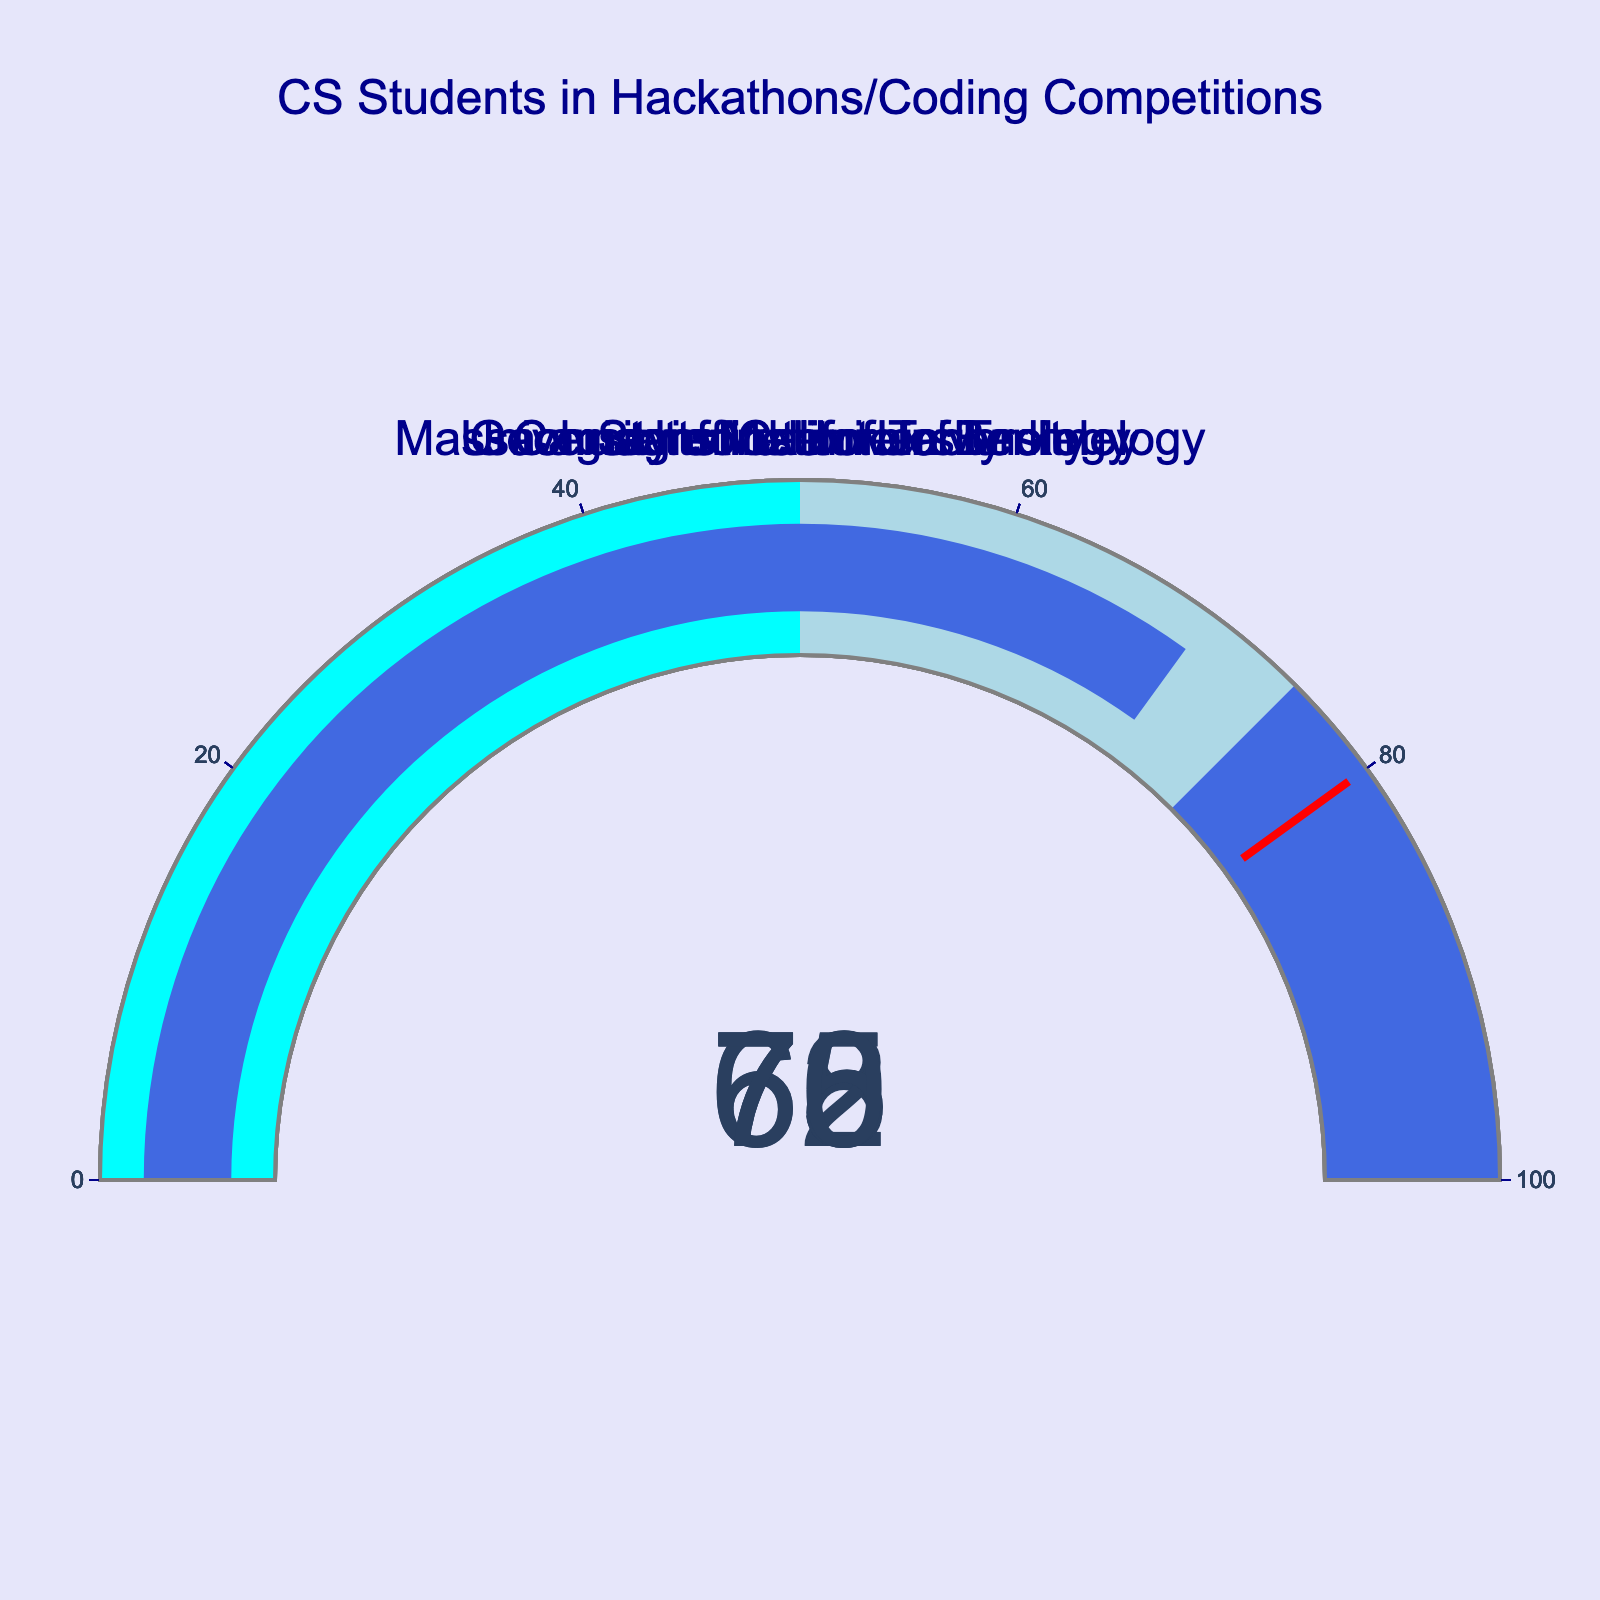What is the title of the figure? The title is displayed at the top of the figure in dark blue font, and it reads "CS Students in Hackathons/Coding Competitions".
Answer: CS Students in Hackathons/Coding Competitions How many universities are included in the figure? The figure includes gauge charts for each of the universities mentioned in the dataset. Counting the names displayed in each gauge chart, we see there are five universities.
Answer: Five Which university has the highest percentage of students participating in hackathons or coding competitions? By looking at each gauge chart, we identify the university with the highest value on the gauge. Carnegie Mellon University shows a value of 75%, which is the highest percentage among the universities.
Answer: Carnegie Mellon University What is the range for the gauge axis? The gauge axis range is indicated with tick marks, and each gauge chart has values ranging from 0 to 100.
Answer: 0 to 100 What percentage of students at the University of California Berkeley participate in hackathons or coding competitions? The gauge chart for the University of California Berkeley shows a value, which is the percentage of students participating in hackathons or coding competitions. This value is 65%.
Answer: 65% Calculate the average percentage of students participating across all universities. We need to sum up the percentages for all universities and then divide by the number of universities: (68 + 72 + 75 + 65 + 70) / 5 = 350 / 5 = 70.
Answer: 70 Which universities have a lower percentage than Georgia Institute of Technology? The gauge chart for Georgia Institute of Technology shows 70%. We compare this with other universities: Stanford University (68%) and University of California Berkeley (65%) are both lower.
Answer: Stanford University and University of California Berkeley Is the percentage of students participating in hackathons/coding competitions at MIT higher than that at Stanford University? MIT's gauge chart shows 72%, while Stanford University's gauge chart shows 68%. Comparing these, 72% is indeed higher than 68%.
Answer: Yes What is the color of the gauge bar for each university when the percentage is between 50 and 75? The gauge charts use a color-coding system: the range of 50 to 75 is indicated by the color light blue.
Answer: Light blue 